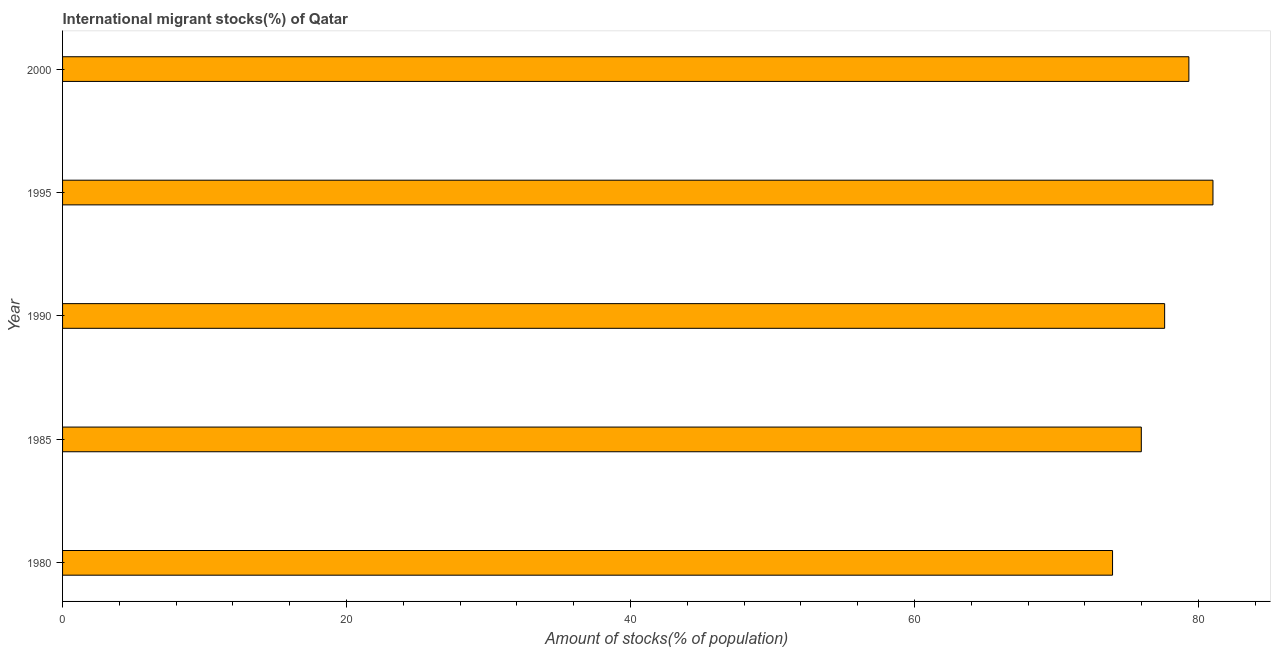Does the graph contain any zero values?
Your answer should be very brief. No. Does the graph contain grids?
Your answer should be very brief. No. What is the title of the graph?
Keep it short and to the point. International migrant stocks(%) of Qatar. What is the label or title of the X-axis?
Offer a terse response. Amount of stocks(% of population). What is the number of international migrant stocks in 1990?
Ensure brevity in your answer.  77.61. Across all years, what is the maximum number of international migrant stocks?
Keep it short and to the point. 81.02. Across all years, what is the minimum number of international migrant stocks?
Ensure brevity in your answer.  73.94. What is the sum of the number of international migrant stocks?
Offer a terse response. 387.87. What is the difference between the number of international migrant stocks in 1985 and 1990?
Provide a succinct answer. -1.64. What is the average number of international migrant stocks per year?
Provide a short and direct response. 77.57. What is the median number of international migrant stocks?
Provide a succinct answer. 77.61. In how many years, is the number of international migrant stocks greater than 64 %?
Make the answer very short. 5. What is the ratio of the number of international migrant stocks in 1985 to that in 2000?
Your answer should be compact. 0.96. Is the number of international migrant stocks in 1980 less than that in 1985?
Make the answer very short. Yes. Is the difference between the number of international migrant stocks in 1995 and 2000 greater than the difference between any two years?
Give a very brief answer. No. What is the difference between the highest and the second highest number of international migrant stocks?
Provide a succinct answer. 1.7. What is the difference between the highest and the lowest number of international migrant stocks?
Your answer should be compact. 7.07. How many bars are there?
Offer a terse response. 5. Are all the bars in the graph horizontal?
Make the answer very short. Yes. How many years are there in the graph?
Make the answer very short. 5. What is the difference between two consecutive major ticks on the X-axis?
Give a very brief answer. 20. Are the values on the major ticks of X-axis written in scientific E-notation?
Ensure brevity in your answer.  No. What is the Amount of stocks(% of population) in 1980?
Your answer should be compact. 73.94. What is the Amount of stocks(% of population) of 1985?
Make the answer very short. 75.97. What is the Amount of stocks(% of population) in 1990?
Ensure brevity in your answer.  77.61. What is the Amount of stocks(% of population) of 1995?
Offer a very short reply. 81.02. What is the Amount of stocks(% of population) of 2000?
Your answer should be very brief. 79.32. What is the difference between the Amount of stocks(% of population) in 1980 and 1985?
Make the answer very short. -2.03. What is the difference between the Amount of stocks(% of population) in 1980 and 1990?
Make the answer very short. -3.67. What is the difference between the Amount of stocks(% of population) in 1980 and 1995?
Provide a succinct answer. -7.07. What is the difference between the Amount of stocks(% of population) in 1980 and 2000?
Your answer should be very brief. -5.38. What is the difference between the Amount of stocks(% of population) in 1985 and 1990?
Ensure brevity in your answer.  -1.64. What is the difference between the Amount of stocks(% of population) in 1985 and 1995?
Provide a succinct answer. -5.05. What is the difference between the Amount of stocks(% of population) in 1985 and 2000?
Your answer should be very brief. -3.35. What is the difference between the Amount of stocks(% of population) in 1990 and 1995?
Keep it short and to the point. -3.4. What is the difference between the Amount of stocks(% of population) in 1990 and 2000?
Provide a short and direct response. -1.71. What is the difference between the Amount of stocks(% of population) in 1995 and 2000?
Provide a short and direct response. 1.7. What is the ratio of the Amount of stocks(% of population) in 1980 to that in 1985?
Give a very brief answer. 0.97. What is the ratio of the Amount of stocks(% of population) in 1980 to that in 1990?
Ensure brevity in your answer.  0.95. What is the ratio of the Amount of stocks(% of population) in 1980 to that in 2000?
Offer a terse response. 0.93. What is the ratio of the Amount of stocks(% of population) in 1985 to that in 1995?
Your answer should be very brief. 0.94. What is the ratio of the Amount of stocks(% of population) in 1985 to that in 2000?
Your answer should be compact. 0.96. What is the ratio of the Amount of stocks(% of population) in 1990 to that in 1995?
Your answer should be compact. 0.96. 